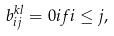<formula> <loc_0><loc_0><loc_500><loc_500>b ^ { k l } _ { i j } = 0 i f i \leq j ,</formula> 